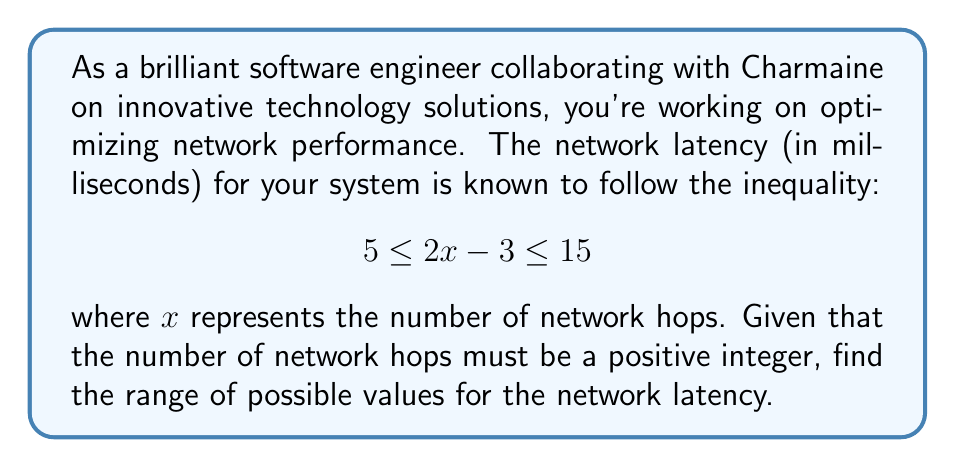Solve this math problem. To solve this problem, we'll follow these steps:

1) First, let's isolate $x$ in the inequality:
   $$ 5 \leq 2x - 3 \leq 15 $$
   Add 3 to all parts of the inequality:
   $$ 8 \leq 2x \leq 18 $$
   Divide all parts by 2:
   $$ 4 \leq x \leq 9 $$

2) Since $x$ represents the number of network hops, it must be a positive integer. Therefore, the possible values for $x$ are 4, 5, 6, 7, 8, and 9.

3) Now, to find the network latency, we need to substitute these values back into the original expression: $2x - 3$

   For $x = 4$: $2(4) - 3 = 5$
   For $x = 5$: $2(5) - 3 = 7$
   For $x = 6$: $2(6) - 3 = 9$
   For $x = 7$: $2(7) - 3 = 11$
   For $x = 8$: $2(8) - 3 = 13$
   For $x = 9$: $2(9) - 3 = 15$

4) Therefore, the possible values for network latency are 5, 7, 9, 11, 13, and 15 milliseconds.

5) The range of these values is from the minimum (5 ms) to the maximum (15 ms).
Answer: The range of possible values for the network latency is $[5, 15]$ milliseconds, or more precisely, the discrete set $\{5, 7, 9, 11, 13, 15\}$ milliseconds. 